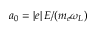<formula> <loc_0><loc_0><loc_500><loc_500>a _ { 0 } = \left | e \right | E / ( m _ { e } \omega _ { L } )</formula> 